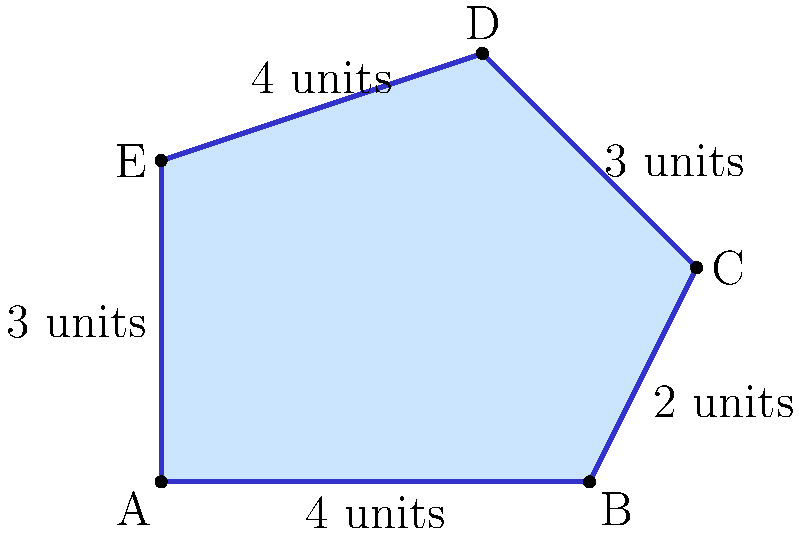As part of an affordable housing initiative, you're analyzing an irregularly shaped plot of land. The plot is represented by the polygon ABCDE in the diagram. Given that each unit in the diagram represents 10 meters, calculate the area of this affordable housing plot in square meters. How does this compare to the minimum plot size of 400 square meters recommended by urban planners for sustainable community development? To calculate the area of this irregular polygon, we can divide it into simpler shapes and sum their areas. Let's break it down step-by-step:

1) Divide the polygon into a rectangle (ABFE) and two triangles (BCE and CDE).

2) Calculate the area of rectangle ABFE:
   Length = 4 units, Width = 3 units
   Area_rectangle = $4 \times 3 = 12$ square units

3) Calculate the area of triangle BCE:
   Base = 1 unit, Height = 2 units
   Area_BCE = $\frac{1 \times 2}{2} = 1$ square unit

4) Calculate the area of triangle CDE:
   Base = 2 units, Height = 1 unit
   Area_CDE = $\frac{2 \times 1}{2} = 1$ square unit

5) Sum up all areas:
   Total Area = $12 + 1 + 1 = 14$ square units

6) Convert to square meters:
   1 unit = 10 meters
   1 square unit = $10 \times 10 = 100$ square meters
   Total Area in m² = $14 \times 100 = 1400$ square meters

7) Compare to the recommended minimum:
   1400 m² > 400 m² (recommended minimum)

The plot is significantly larger than the minimum recommended size, potentially allowing for more spacious housing units or additional community amenities.
Answer: 1400 m²; 3.5 times the recommended minimum 